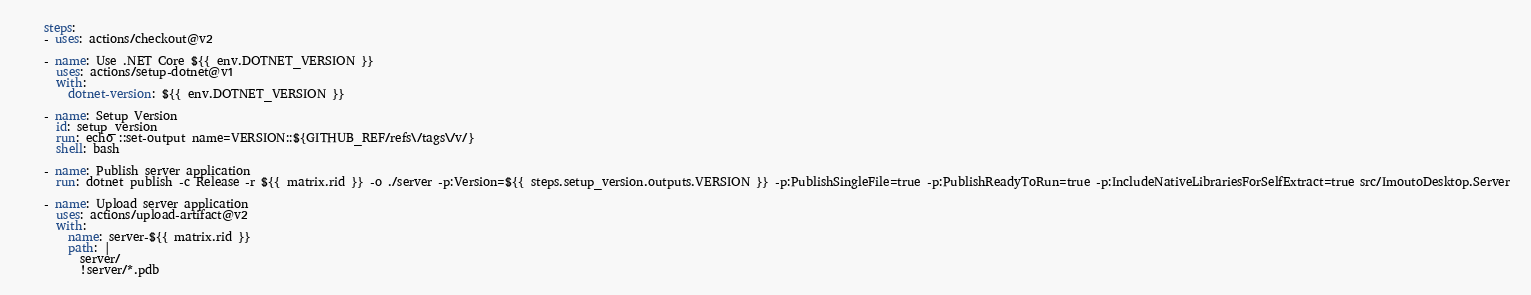Convert code to text. <code><loc_0><loc_0><loc_500><loc_500><_YAML_>    steps:
    - uses: actions/checkout@v2

    - name: Use .NET Core ${{ env.DOTNET_VERSION }}
      uses: actions/setup-dotnet@v1
      with:
        dotnet-version: ${{ env.DOTNET_VERSION }}

    - name: Setup Version
      id: setup_version
      run: echo ::set-output name=VERSION::${GITHUB_REF/refs\/tags\/v/}
      shell: bash

    - name: Publish server application
      run: dotnet publish -c Release -r ${{ matrix.rid }} -o ./server -p:Version=${{ steps.setup_version.outputs.VERSION }} -p:PublishSingleFile=true -p:PublishReadyToRun=true -p:IncludeNativeLibrariesForSelfExtract=true src/ImoutoDesktop.Server

    - name: Upload server application
      uses: actions/upload-artifact@v2
      with:
        name: server-${{ matrix.rid }}
        path: |
          server/
          !server/*.pdb
</code> 